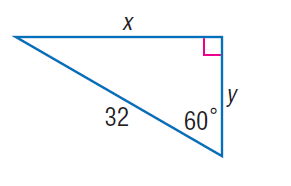Question: Find y.
Choices:
A. 8
B. 16
C. 16 \sqrt { 3 }
D. 16 \sqrt { 3 }
Answer with the letter. Answer: B 